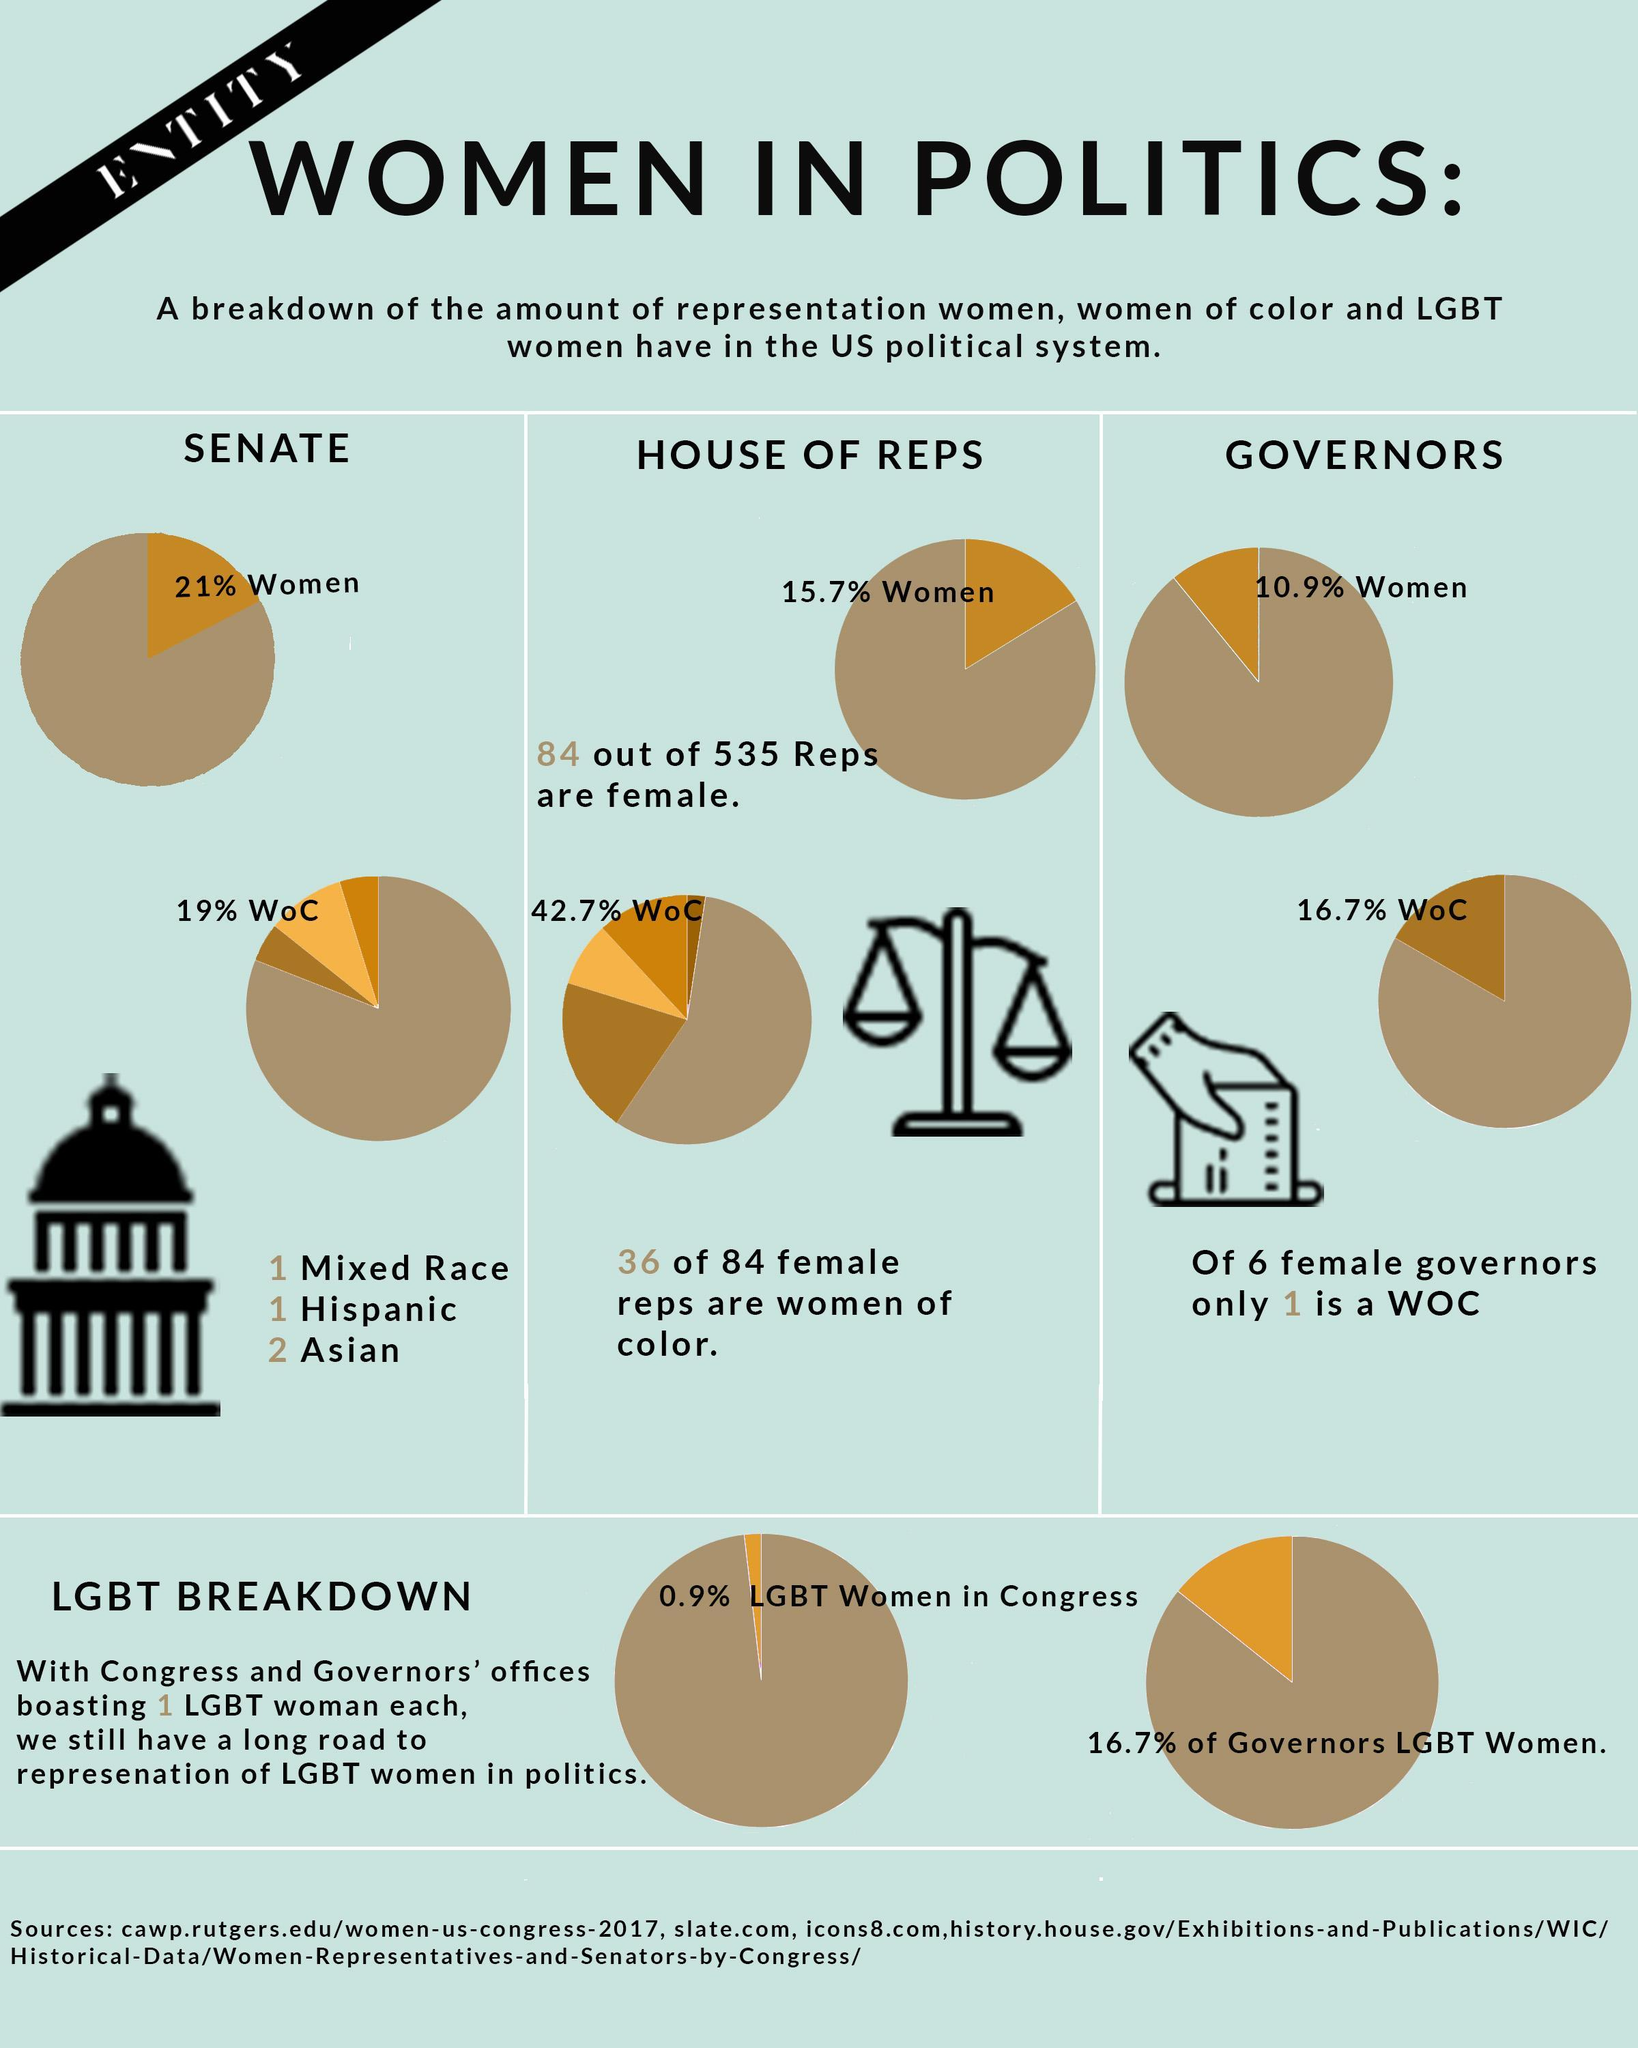Out of 535 reps., how many are not females
Answer the question with a short phrase. 451 What races does WOC comprise of Mixed race, Hispanic, Asian What is the % of governors who are not women 89.1 What % of the senate are not women 79 